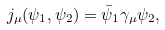Convert formula to latex. <formula><loc_0><loc_0><loc_500><loc_500>j _ { \mu } ( \psi _ { 1 } , \psi _ { 2 } ) = \bar { \psi } _ { 1 } \gamma _ { \mu } \psi _ { 2 } ,</formula> 